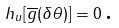Convert formula to latex. <formula><loc_0><loc_0><loc_500><loc_500>h _ { u } [ \overline { g } ( \delta \theta ) ] = 0 \, \text {.}</formula> 